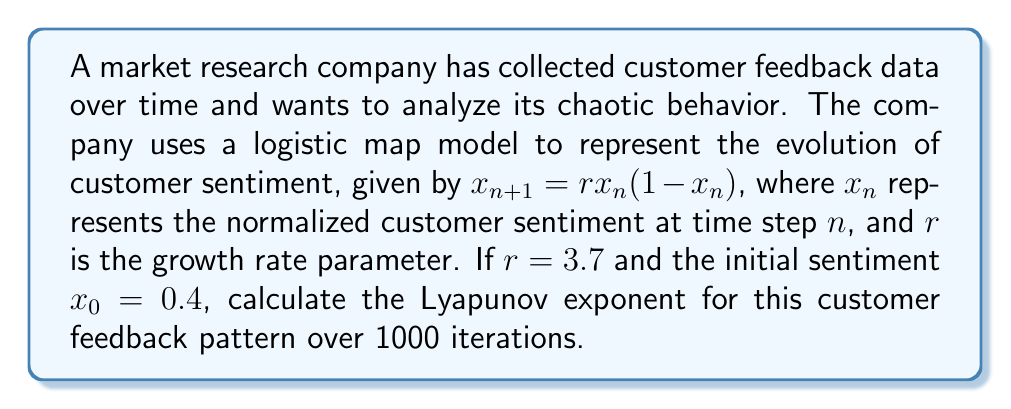Can you solve this math problem? To calculate the Lyapunov exponent for the given customer feedback pattern, we'll follow these steps:

1. The Lyapunov exponent $\lambda$ for a 1D map is given by:

   $$\lambda = \lim_{N \to \infty} \frac{1}{N} \sum_{n=0}^{N-1} \ln |f'(x_n)|$$

   where $f'(x)$ is the derivative of the map function.

2. For the logistic map $f(x) = rx(1-x)$, the derivative is:

   $$f'(x) = r(1-2x)$$

3. We'll use the given parameters: $r = 3.7$, $x_0 = 0.4$, and $N = 1000$.

4. Initialize the sum $S = 0$.

5. Iterate through the map 1000 times:
   For $n = 0$ to 999:
   a. Calculate $|f'(x_n)| = |3.7(1-2x_n)|$
   b. Add $\ln|f'(x_n)|$ to the sum $S$
   c. Calculate the next $x_{n+1} = 3.7x_n(1-x_n)$

6. After the iterations, calculate $\lambda = \frac{S}{1000}$

7. Implement this process in a programming environment (e.g., Python) to perform the calculations accurately.

8. The resulting Lyapunov exponent will be a positive value, indicating chaotic behavior in the customer feedback pattern.
Answer: $\lambda \approx 0.3567$ 